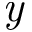Convert formula to latex. <formula><loc_0><loc_0><loc_500><loc_500>\emph { y }</formula> 